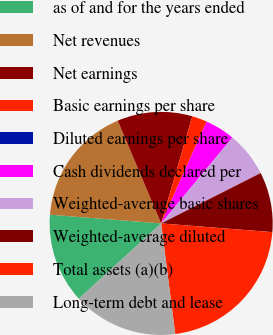Convert chart to OTSL. <chart><loc_0><loc_0><loc_500><loc_500><pie_chart><fcel>as of and for the years ended<fcel>Net revenues<fcel>Net earnings<fcel>Basic earnings per share<fcel>Diluted earnings per share<fcel>Cash dividends declared per<fcel>Weighted-average basic shares<fcel>Weighted-average diluted<fcel>Total assets (a)(b)<fcel>Long-term debt and lease<nl><fcel>13.04%<fcel>17.39%<fcel>10.87%<fcel>2.17%<fcel>0.0%<fcel>4.35%<fcel>6.52%<fcel>8.7%<fcel>21.74%<fcel>15.22%<nl></chart> 